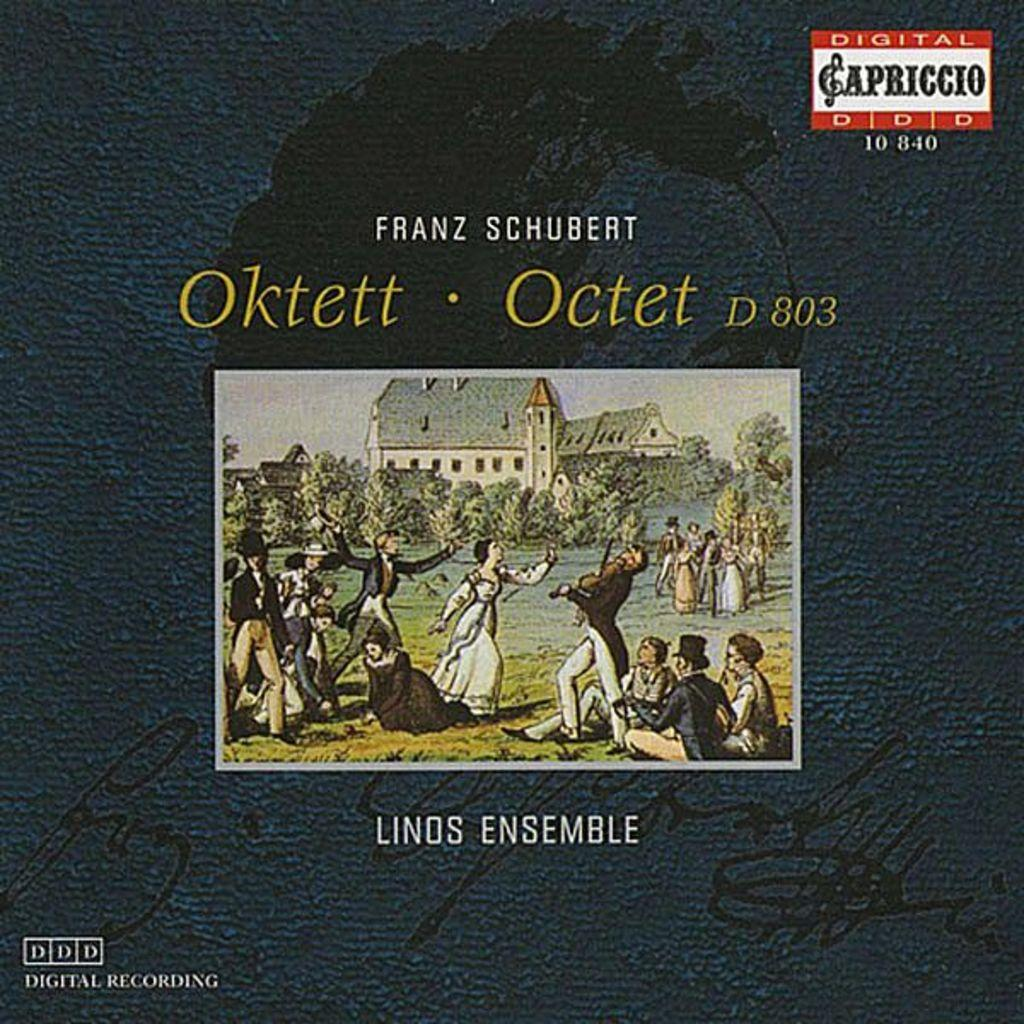<image>
Create a compact narrative representing the image presented. A digital recording by Franz Schubert is displayed. 